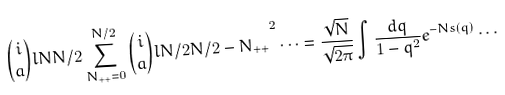<formula> <loc_0><loc_0><loc_500><loc_500>\binom { i } { a } l { N } { N / 2 } \sum _ { N _ { + + } = 0 } ^ { N / 2 } { \binom { i } { a } l { N / 2 } { N / 2 - N _ { + + } } } ^ { 2 } \cdots = \frac { \sqrt { N } } { \sqrt { 2 \pi } } \int \frac { d q } { 1 - q ^ { 2 } } e ^ { - N s ( q ) } \cdots</formula> 